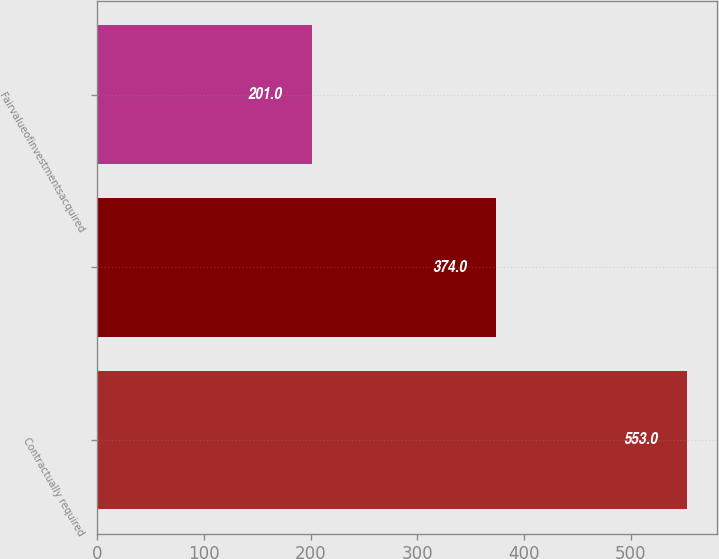Convert chart to OTSL. <chart><loc_0><loc_0><loc_500><loc_500><bar_chart><fcel>Contractually required<fcel>Unnamed: 1<fcel>Fairvalueofinvestmentsacquired<nl><fcel>553<fcel>374<fcel>201<nl></chart> 